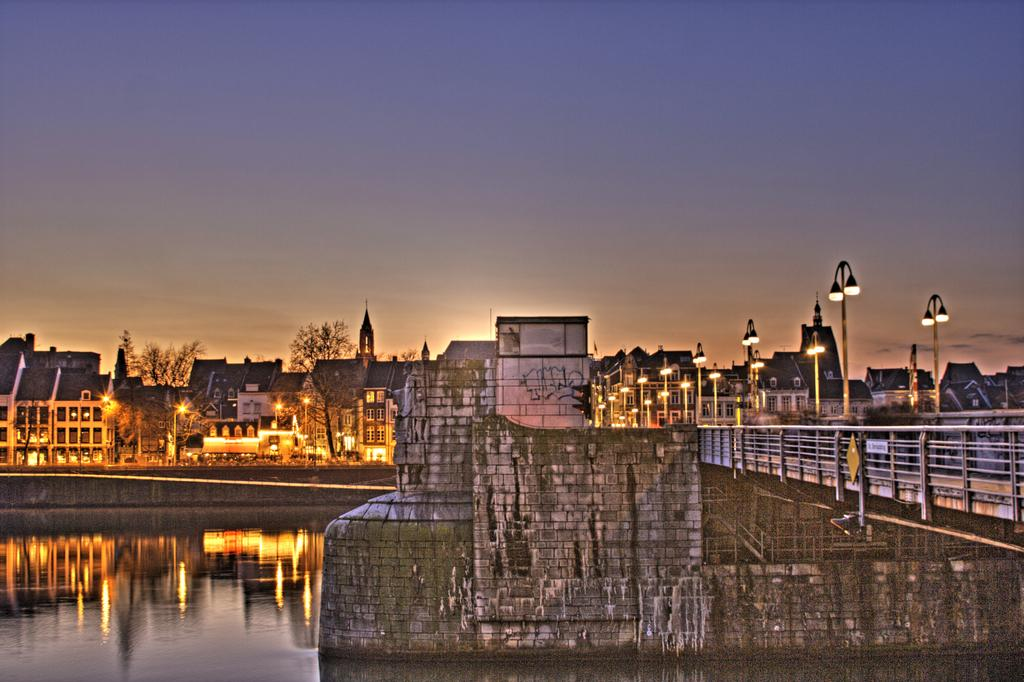What is located at the bottom of the image? There is a lake at the bottom of the image. What can be seen in the center of the image? There are buildings in the center of the image. What is on the right side of the image? There is a fence on the right side of the image. What else is visible in the image besides the lake, buildings, and fence? There are poles visible in the image. What can be seen in the background of the image? There are trees and the sky visible in the background of the image. What type of toothpaste is being used to draw on the buildings in the image? There is no toothpaste or drawing on the buildings in the image. How does the pencil contribute to the health of the trees in the background? There is no pencil or mention of health in the image; it only features a lake, buildings, a fence, poles, trees, and the sky. 